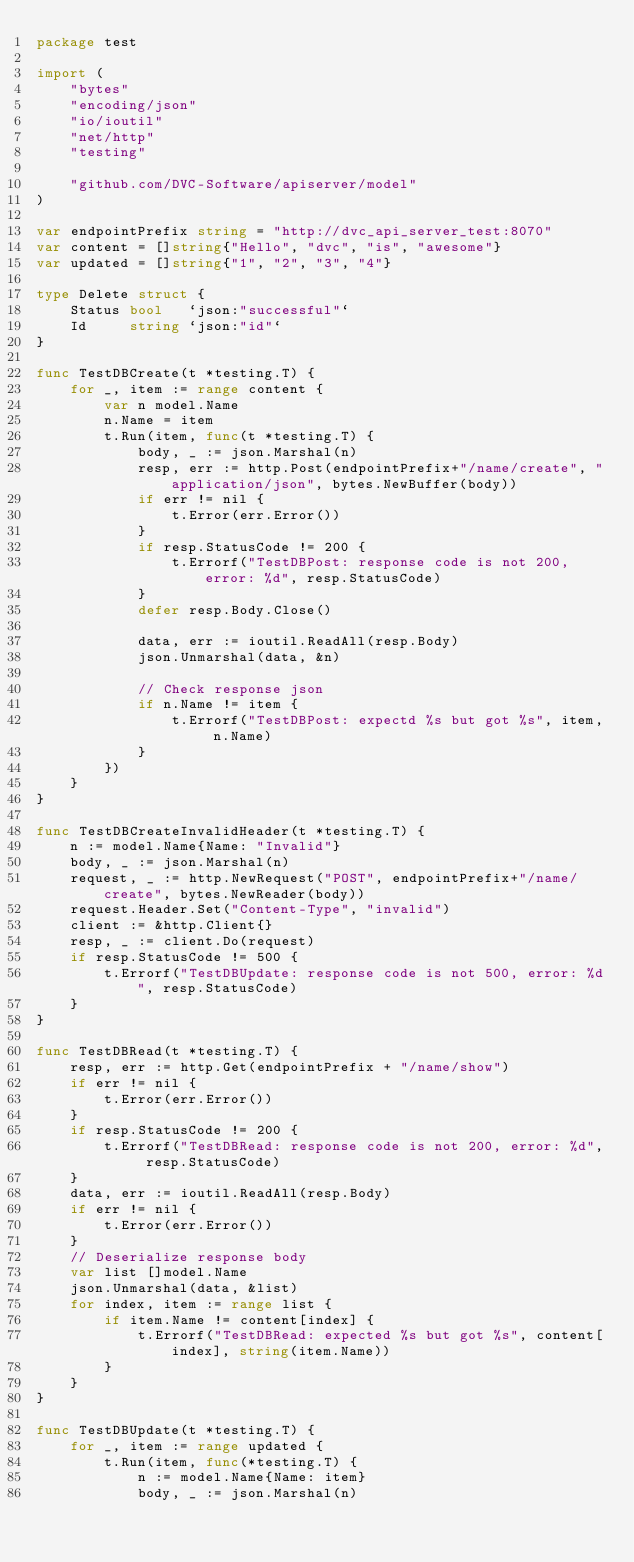<code> <loc_0><loc_0><loc_500><loc_500><_Go_>package test

import (
	"bytes"
	"encoding/json"
	"io/ioutil"
	"net/http"
	"testing"

	"github.com/DVC-Software/apiserver/model"
)

var endpointPrefix string = "http://dvc_api_server_test:8070"
var content = []string{"Hello", "dvc", "is", "awesome"}
var updated = []string{"1", "2", "3", "4"}

type Delete struct {
	Status bool   `json:"successful"`
	Id     string `json:"id"`
}

func TestDBCreate(t *testing.T) {
	for _, item := range content {
		var n model.Name
		n.Name = item
		t.Run(item, func(t *testing.T) {
			body, _ := json.Marshal(n)
			resp, err := http.Post(endpointPrefix+"/name/create", "application/json", bytes.NewBuffer(body))
			if err != nil {
				t.Error(err.Error())
			}
			if resp.StatusCode != 200 {
				t.Errorf("TestDBPost: response code is not 200, error: %d", resp.StatusCode)
			}
			defer resp.Body.Close()

			data, err := ioutil.ReadAll(resp.Body)
			json.Unmarshal(data, &n)

			// Check response json
			if n.Name != item {
				t.Errorf("TestDBPost: expectd %s but got %s", item, n.Name)
			}
		})
	}
}

func TestDBCreateInvalidHeader(t *testing.T) {
	n := model.Name{Name: "Invalid"}
	body, _ := json.Marshal(n)
	request, _ := http.NewRequest("POST", endpointPrefix+"/name/create", bytes.NewReader(body))
	request.Header.Set("Content-Type", "invalid")
	client := &http.Client{}
	resp, _ := client.Do(request)
	if resp.StatusCode != 500 {
		t.Errorf("TestDBUpdate: response code is not 500, error: %d", resp.StatusCode)
	}
}

func TestDBRead(t *testing.T) {
	resp, err := http.Get(endpointPrefix + "/name/show")
	if err != nil {
		t.Error(err.Error())
	}
	if resp.StatusCode != 200 {
		t.Errorf("TestDBRead: response code is not 200, error: %d", resp.StatusCode)
	}
	data, err := ioutil.ReadAll(resp.Body)
	if err != nil {
		t.Error(err.Error())
	}
	// Deserialize response body
	var list []model.Name
	json.Unmarshal(data, &list)
	for index, item := range list {
		if item.Name != content[index] {
			t.Errorf("TestDBRead: expected %s but got %s", content[index], string(item.Name))
		}
	}
}

func TestDBUpdate(t *testing.T) {
	for _, item := range updated {
		t.Run(item, func(*testing.T) {
			n := model.Name{Name: item}
			body, _ := json.Marshal(n)</code> 